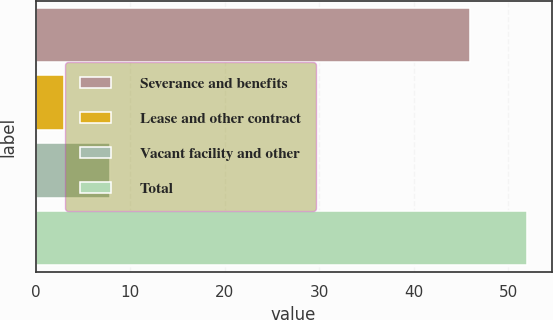Convert chart to OTSL. <chart><loc_0><loc_0><loc_500><loc_500><bar_chart><fcel>Severance and benefits<fcel>Lease and other contract<fcel>Vacant facility and other<fcel>Total<nl><fcel>46<fcel>3<fcel>7.9<fcel>52<nl></chart> 